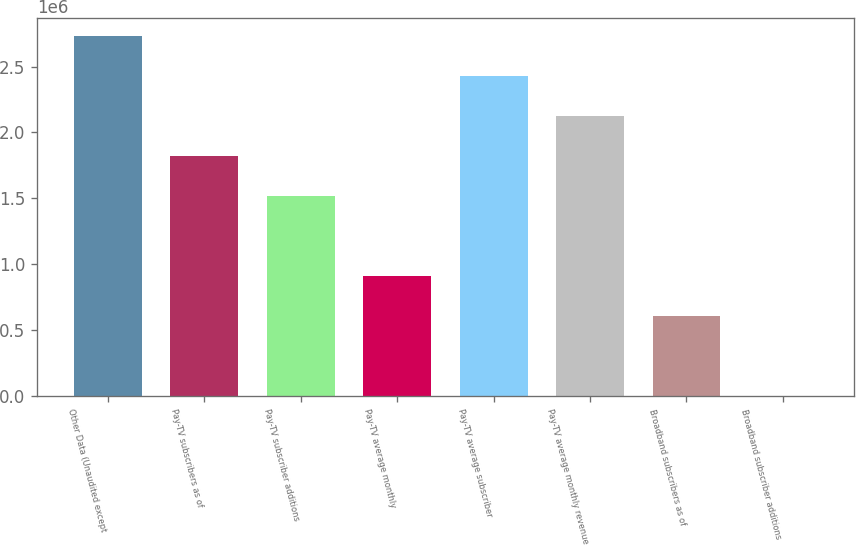<chart> <loc_0><loc_0><loc_500><loc_500><bar_chart><fcel>Other Data (Unaudited except<fcel>Pay-TV subscribers as of<fcel>Pay-TV subscriber additions<fcel>Pay-TV average monthly<fcel>Pay-TV average subscriber<fcel>Pay-TV average monthly revenue<fcel>Broadband subscribers as of<fcel>Broadband subscriber additions<nl><fcel>2.73137e+06<fcel>1.82091e+06<fcel>1.51743e+06<fcel>910457<fcel>2.42789e+06<fcel>2.1244e+06<fcel>606972<fcel>0.25<nl></chart> 